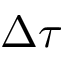<formula> <loc_0><loc_0><loc_500><loc_500>\Delta \tau</formula> 